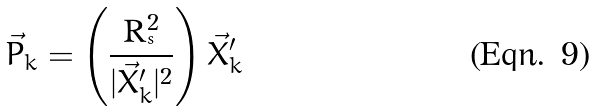Convert formula to latex. <formula><loc_0><loc_0><loc_500><loc_500>\vec { P } _ { k } = \left ( \frac { \text {R} _ { ^ { s } } ^ { 2 } } { | \vec { X } ^ { \prime } _ { k } | ^ { 2 } } \right ) \vec { X } ^ { \prime } _ { k }</formula> 